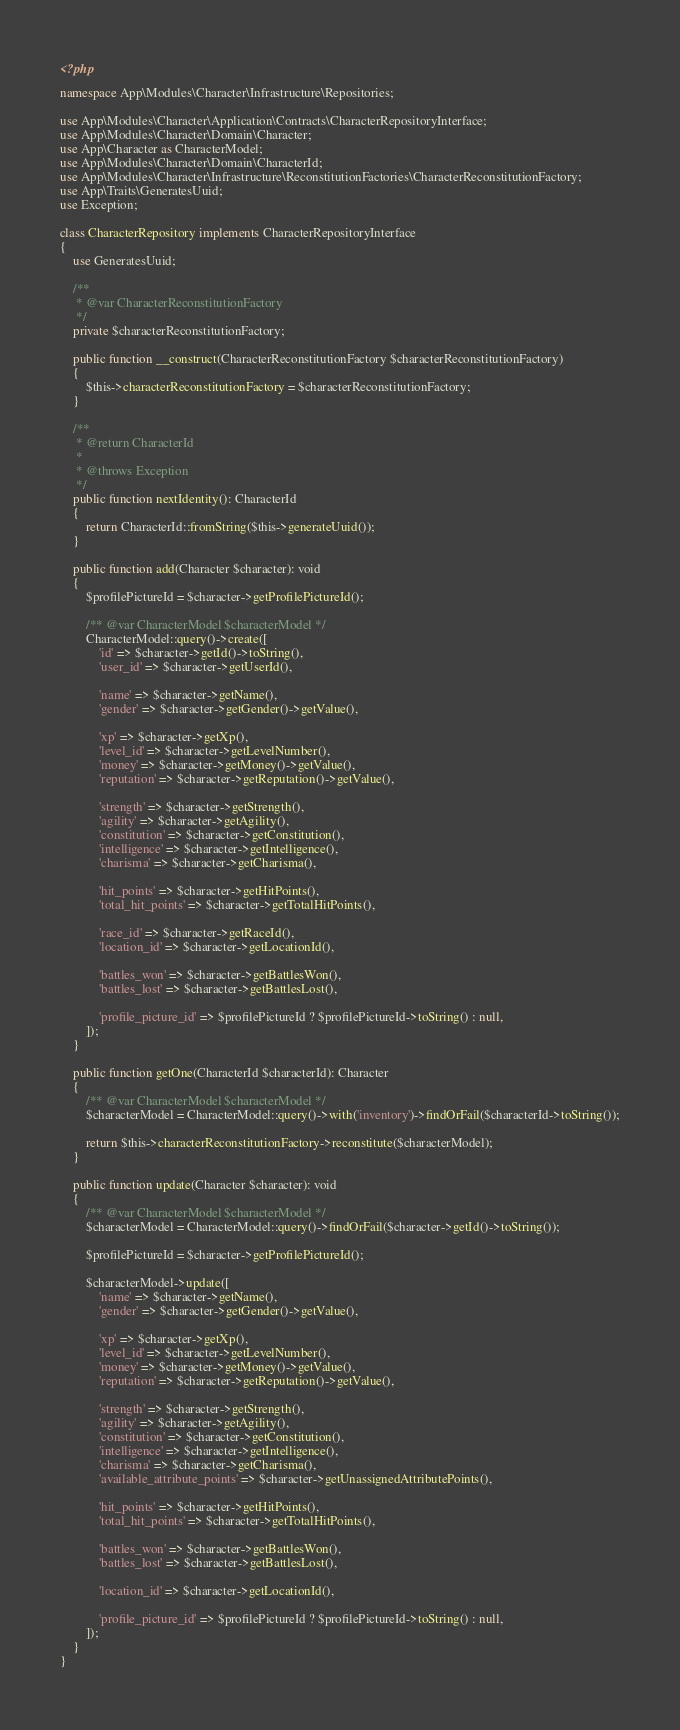Convert code to text. <code><loc_0><loc_0><loc_500><loc_500><_PHP_><?php

namespace App\Modules\Character\Infrastructure\Repositories;

use App\Modules\Character\Application\Contracts\CharacterRepositoryInterface;
use App\Modules\Character\Domain\Character;
use App\Character as CharacterModel;
use App\Modules\Character\Domain\CharacterId;
use App\Modules\Character\Infrastructure\ReconstitutionFactories\CharacterReconstitutionFactory;
use App\Traits\GeneratesUuid;
use Exception;

class CharacterRepository implements CharacterRepositoryInterface
{
    use GeneratesUuid;

    /**
     * @var CharacterReconstitutionFactory
     */
    private $characterReconstitutionFactory;

    public function __construct(CharacterReconstitutionFactory $characterReconstitutionFactory)
    {
        $this->characterReconstitutionFactory = $characterReconstitutionFactory;
    }

    /**
     * @return CharacterId
     *
     * @throws Exception
     */
    public function nextIdentity(): CharacterId
    {
        return CharacterId::fromString($this->generateUuid());
    }

    public function add(Character $character): void
    {
        $profilePictureId = $character->getProfilePictureId();

        /** @var CharacterModel $characterModel */
        CharacterModel::query()->create([
            'id' => $character->getId()->toString(),
            'user_id' => $character->getUserId(),

            'name' => $character->getName(),
            'gender' => $character->getGender()->getValue(),

            'xp' => $character->getXp(),
            'level_id' => $character->getLevelNumber(),
            'money' => $character->getMoney()->getValue(),
            'reputation' => $character->getReputation()->getValue(),

            'strength' => $character->getStrength(),
            'agility' => $character->getAgility(),
            'constitution' => $character->getConstitution(),
            'intelligence' => $character->getIntelligence(),
            'charisma' => $character->getCharisma(),

            'hit_points' => $character->getHitPoints(),
            'total_hit_points' => $character->getTotalHitPoints(),

            'race_id' => $character->getRaceId(),
            'location_id' => $character->getLocationId(),

            'battles_won' => $character->getBattlesWon(),
            'battles_lost' => $character->getBattlesLost(),

            'profile_picture_id' => $profilePictureId ? $profilePictureId->toString() : null,
        ]);
    }

    public function getOne(CharacterId $characterId): Character
    {
        /** @var CharacterModel $characterModel */
        $characterModel = CharacterModel::query()->with('inventory')->findOrFail($characterId->toString());

        return $this->characterReconstitutionFactory->reconstitute($characterModel);
    }

    public function update(Character $character): void
    {
        /** @var CharacterModel $characterModel */
        $characterModel = CharacterModel::query()->findOrFail($character->getId()->toString());

        $profilePictureId = $character->getProfilePictureId();

        $characterModel->update([
            'name' => $character->getName(),
            'gender' => $character->getGender()->getValue(),

            'xp' => $character->getXp(),
            'level_id' => $character->getLevelNumber(),
            'money' => $character->getMoney()->getValue(),
            'reputation' => $character->getReputation()->getValue(),

            'strength' => $character->getStrength(),
            'agility' => $character->getAgility(),
            'constitution' => $character->getConstitution(),
            'intelligence' => $character->getIntelligence(),
            'charisma' => $character->getCharisma(),
            'available_attribute_points' => $character->getUnassignedAttributePoints(),

            'hit_points' => $character->getHitPoints(),
            'total_hit_points' => $character->getTotalHitPoints(),

            'battles_won' => $character->getBattlesWon(),
            'battles_lost' => $character->getBattlesLost(),

            'location_id' => $character->getLocationId(),

            'profile_picture_id' => $profilePictureId ? $profilePictureId->toString() : null,
        ]);
    }
}
</code> 